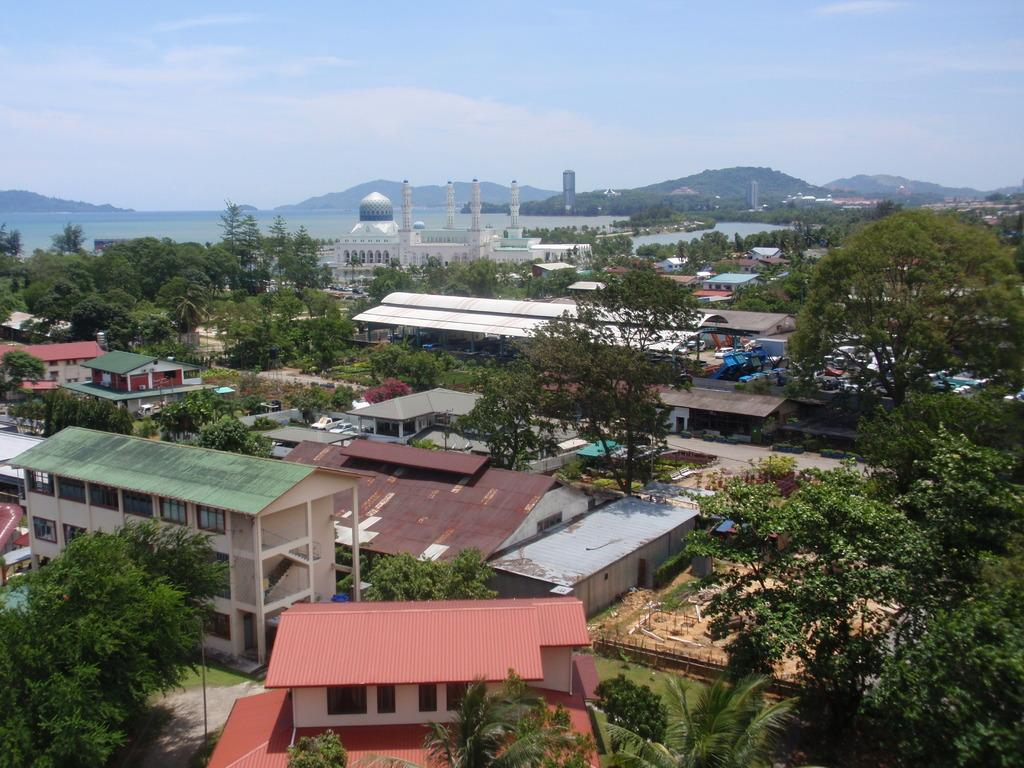What type of natural elements can be seen in the image? There are trees in the image. What type of man-made structures are present in the image? There are houses and buildings in the image. What is visible in the background of the image? The sky is visible in the image. What type of brake is visible in the image? There is no brake present in the image. Can you identify a woman in the image? There is no woman present in the image. 